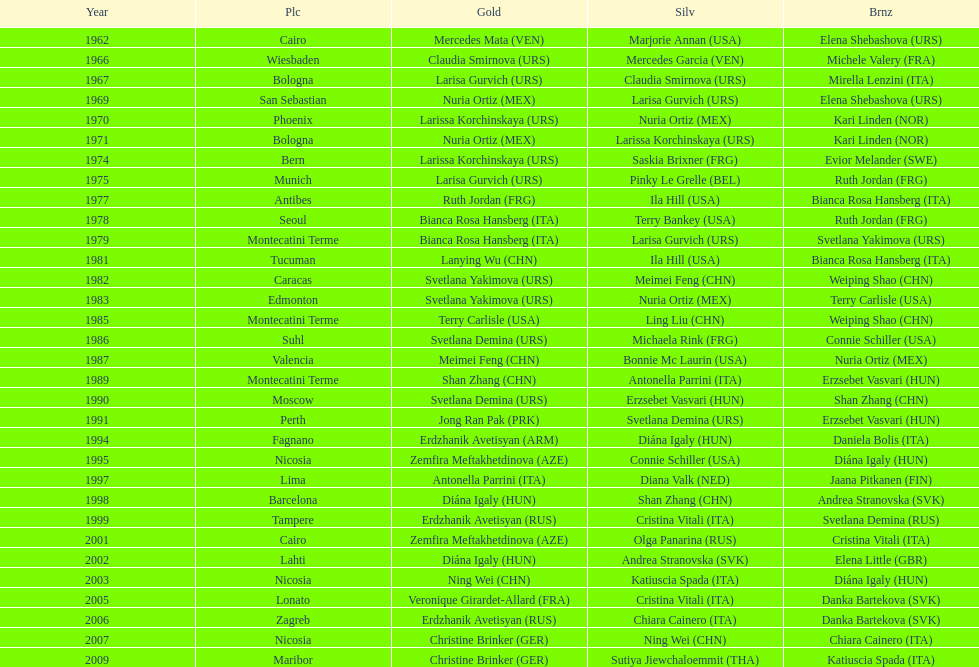What is the total amount of winnings for the united states in gold, silver and bronze? 9. 